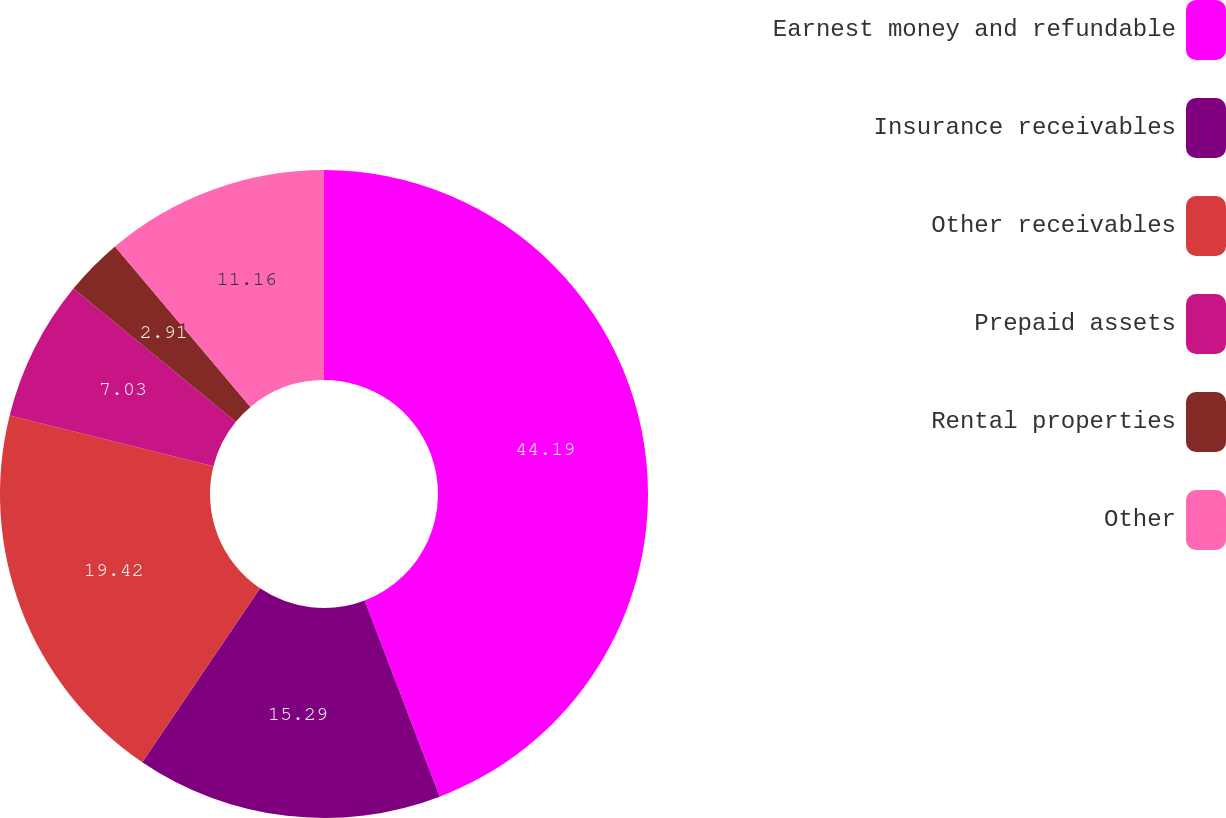Convert chart to OTSL. <chart><loc_0><loc_0><loc_500><loc_500><pie_chart><fcel>Earnest money and refundable<fcel>Insurance receivables<fcel>Other receivables<fcel>Prepaid assets<fcel>Rental properties<fcel>Other<nl><fcel>44.19%<fcel>15.29%<fcel>19.42%<fcel>7.03%<fcel>2.91%<fcel>11.16%<nl></chart> 